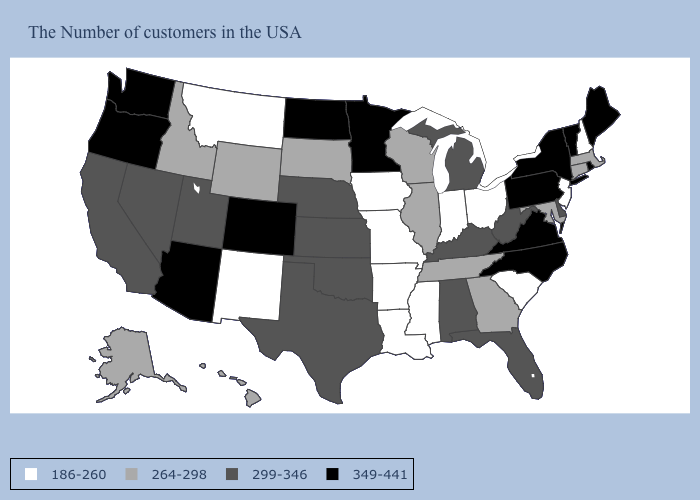What is the value of Louisiana?
Keep it brief. 186-260. Among the states that border Oklahoma , does Colorado have the highest value?
Quick response, please. Yes. Which states have the lowest value in the USA?
Be succinct. New Hampshire, New Jersey, South Carolina, Ohio, Indiana, Mississippi, Louisiana, Missouri, Arkansas, Iowa, New Mexico, Montana. What is the highest value in the USA?
Concise answer only. 349-441. Name the states that have a value in the range 186-260?
Short answer required. New Hampshire, New Jersey, South Carolina, Ohio, Indiana, Mississippi, Louisiana, Missouri, Arkansas, Iowa, New Mexico, Montana. Among the states that border New Hampshire , does Massachusetts have the lowest value?
Be succinct. Yes. What is the value of Illinois?
Short answer required. 264-298. What is the highest value in states that border Indiana?
Write a very short answer. 299-346. Name the states that have a value in the range 299-346?
Quick response, please. Delaware, West Virginia, Florida, Michigan, Kentucky, Alabama, Kansas, Nebraska, Oklahoma, Texas, Utah, Nevada, California. What is the value of Michigan?
Keep it brief. 299-346. Name the states that have a value in the range 264-298?
Be succinct. Massachusetts, Connecticut, Maryland, Georgia, Tennessee, Wisconsin, Illinois, South Dakota, Wyoming, Idaho, Alaska, Hawaii. What is the value of North Carolina?
Keep it brief. 349-441. Does Louisiana have the lowest value in the South?
Quick response, please. Yes. Among the states that border Wisconsin , which have the highest value?
Short answer required. Minnesota. Does New Hampshire have the lowest value in the Northeast?
Give a very brief answer. Yes. 